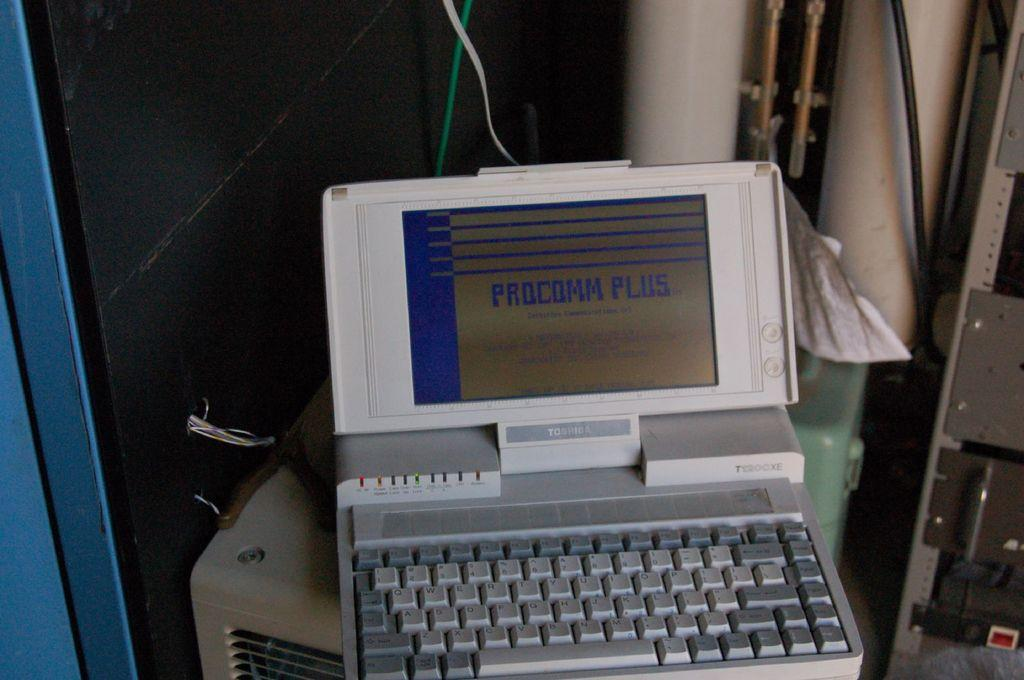<image>
Present a compact description of the photo's key features. The computer has the word Procomm Plus on screen 